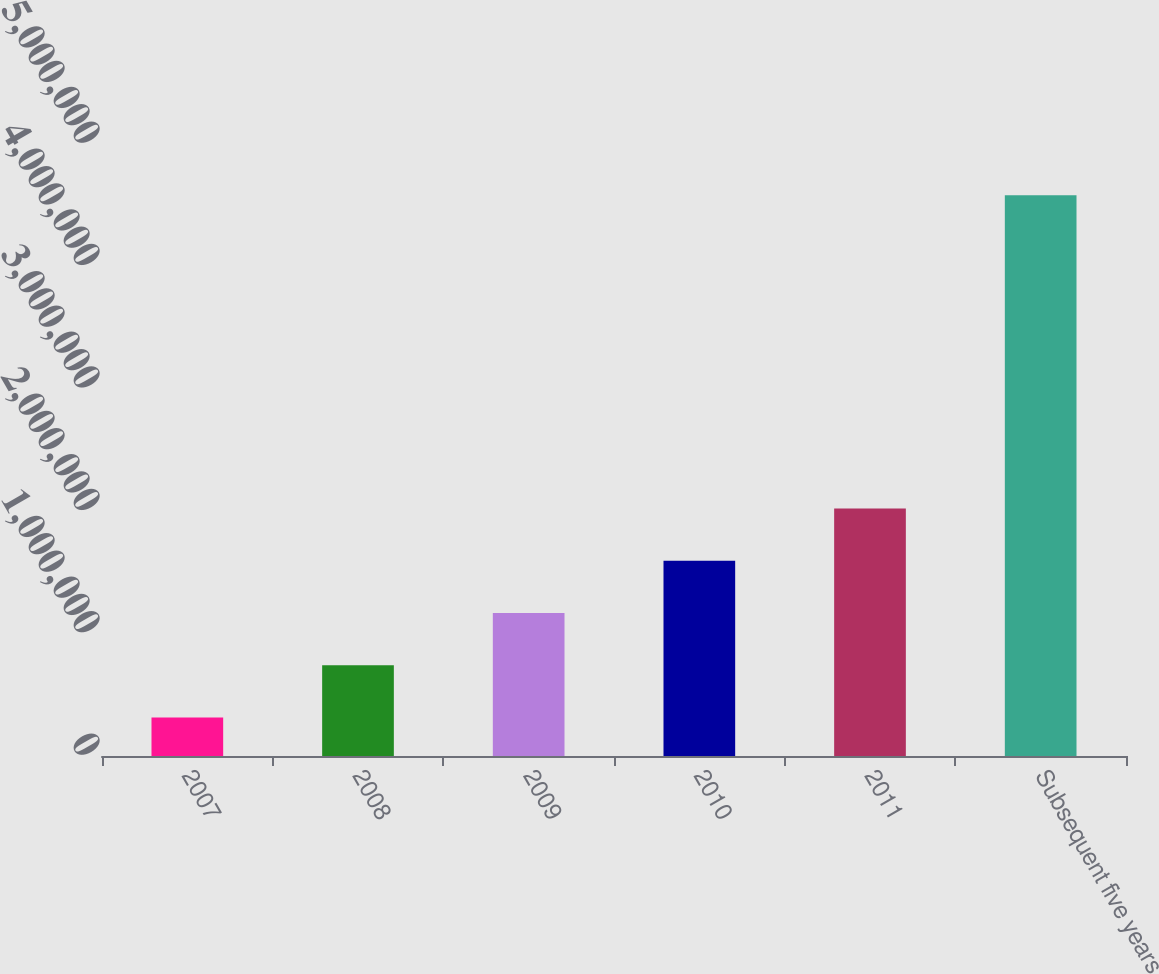Convert chart. <chart><loc_0><loc_0><loc_500><loc_500><bar_chart><fcel>2007<fcel>2008<fcel>2009<fcel>2010<fcel>2011<fcel>Subsequent five years<nl><fcel>315000<fcel>741600<fcel>1.1682e+06<fcel>1.5948e+06<fcel>2.0214e+06<fcel>4.581e+06<nl></chart> 